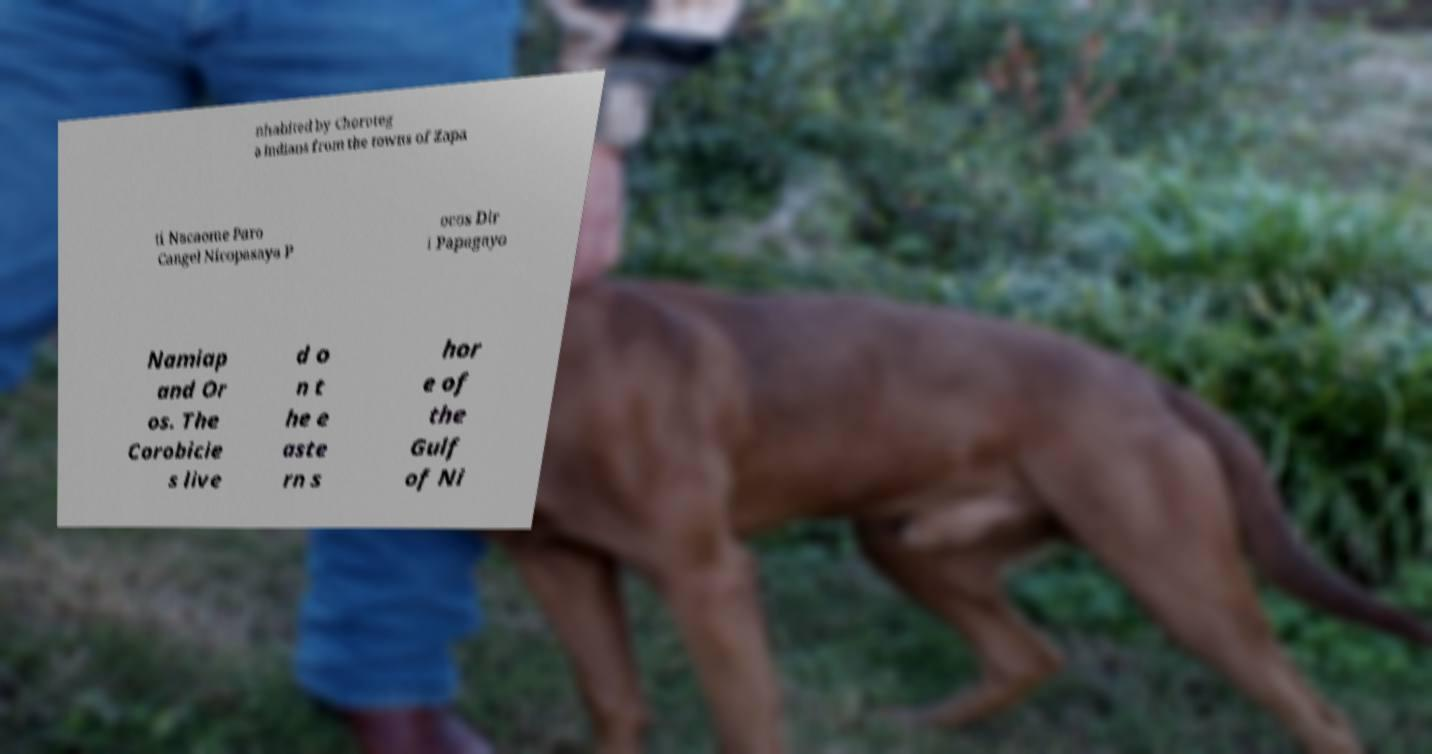Can you read and provide the text displayed in the image?This photo seems to have some interesting text. Can you extract and type it out for me? nhabited by Choroteg a Indians from the towns of Zapa ti Nacaome Paro Cangel Nicopasaya P ocos Dir i Papagayo Namiap and Or os. The Corobicie s live d o n t he e aste rn s hor e of the Gulf of Ni 